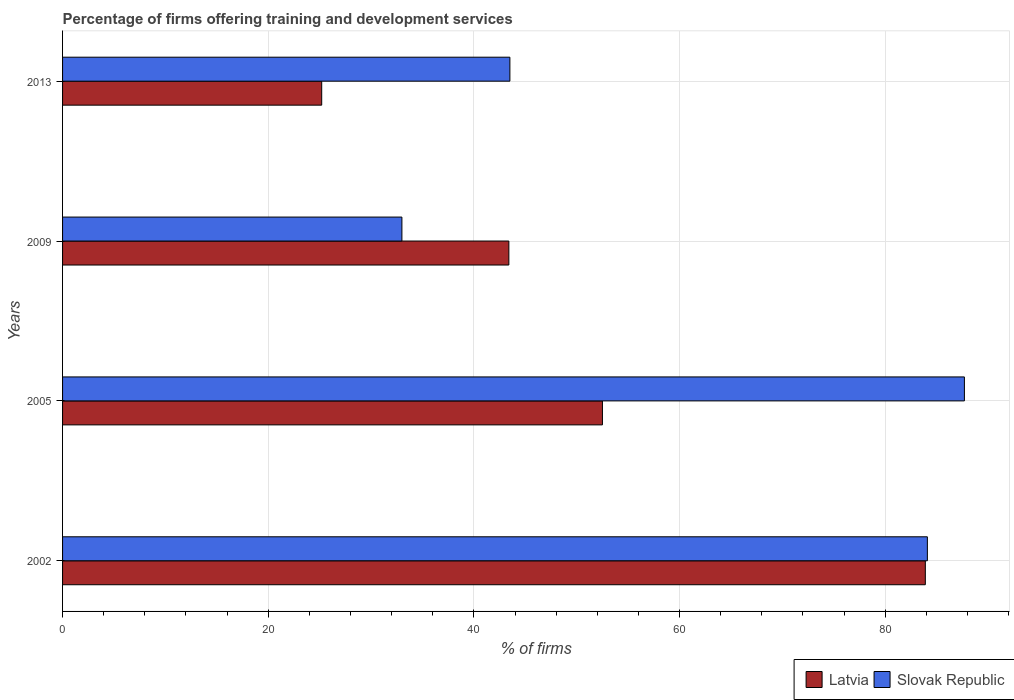How many different coloured bars are there?
Provide a short and direct response. 2. How many groups of bars are there?
Your answer should be compact. 4. Are the number of bars per tick equal to the number of legend labels?
Provide a short and direct response. Yes. Are the number of bars on each tick of the Y-axis equal?
Your response must be concise. Yes. How many bars are there on the 1st tick from the bottom?
Make the answer very short. 2. What is the percentage of firms offering training and development in Latvia in 2002?
Ensure brevity in your answer.  83.9. Across all years, what is the maximum percentage of firms offering training and development in Latvia?
Your answer should be compact. 83.9. Across all years, what is the minimum percentage of firms offering training and development in Latvia?
Give a very brief answer. 25.2. What is the total percentage of firms offering training and development in Slovak Republic in the graph?
Ensure brevity in your answer.  248.3. What is the difference between the percentage of firms offering training and development in Slovak Republic in 2002 and that in 2005?
Your response must be concise. -3.6. What is the difference between the percentage of firms offering training and development in Slovak Republic in 2005 and the percentage of firms offering training and development in Latvia in 2002?
Your answer should be very brief. 3.8. What is the average percentage of firms offering training and development in Latvia per year?
Keep it short and to the point. 51.25. In the year 2009, what is the difference between the percentage of firms offering training and development in Latvia and percentage of firms offering training and development in Slovak Republic?
Offer a terse response. 10.4. What is the ratio of the percentage of firms offering training and development in Slovak Republic in 2002 to that in 2013?
Your answer should be very brief. 1.93. Is the percentage of firms offering training and development in Latvia in 2002 less than that in 2005?
Make the answer very short. No. Is the difference between the percentage of firms offering training and development in Latvia in 2002 and 2005 greater than the difference between the percentage of firms offering training and development in Slovak Republic in 2002 and 2005?
Your answer should be compact. Yes. What is the difference between the highest and the second highest percentage of firms offering training and development in Latvia?
Ensure brevity in your answer.  31.4. What is the difference between the highest and the lowest percentage of firms offering training and development in Latvia?
Your answer should be very brief. 58.7. What does the 2nd bar from the top in 2009 represents?
Your answer should be very brief. Latvia. What does the 1st bar from the bottom in 2002 represents?
Ensure brevity in your answer.  Latvia. Are all the bars in the graph horizontal?
Your answer should be compact. Yes. How many years are there in the graph?
Provide a succinct answer. 4. Where does the legend appear in the graph?
Give a very brief answer. Bottom right. How many legend labels are there?
Give a very brief answer. 2. What is the title of the graph?
Offer a terse response. Percentage of firms offering training and development services. Does "Bahamas" appear as one of the legend labels in the graph?
Provide a short and direct response. No. What is the label or title of the X-axis?
Your answer should be very brief. % of firms. What is the % of firms of Latvia in 2002?
Your answer should be very brief. 83.9. What is the % of firms of Slovak Republic in 2002?
Ensure brevity in your answer.  84.1. What is the % of firms of Latvia in 2005?
Give a very brief answer. 52.5. What is the % of firms of Slovak Republic in 2005?
Offer a very short reply. 87.7. What is the % of firms of Latvia in 2009?
Make the answer very short. 43.4. What is the % of firms of Latvia in 2013?
Your answer should be compact. 25.2. What is the % of firms in Slovak Republic in 2013?
Make the answer very short. 43.5. Across all years, what is the maximum % of firms of Latvia?
Offer a very short reply. 83.9. Across all years, what is the maximum % of firms of Slovak Republic?
Your response must be concise. 87.7. Across all years, what is the minimum % of firms in Latvia?
Give a very brief answer. 25.2. What is the total % of firms in Latvia in the graph?
Your answer should be compact. 205. What is the total % of firms of Slovak Republic in the graph?
Your answer should be very brief. 248.3. What is the difference between the % of firms in Latvia in 2002 and that in 2005?
Offer a very short reply. 31.4. What is the difference between the % of firms in Slovak Republic in 2002 and that in 2005?
Offer a terse response. -3.6. What is the difference between the % of firms in Latvia in 2002 and that in 2009?
Keep it short and to the point. 40.5. What is the difference between the % of firms of Slovak Republic in 2002 and that in 2009?
Keep it short and to the point. 51.1. What is the difference between the % of firms in Latvia in 2002 and that in 2013?
Your answer should be very brief. 58.7. What is the difference between the % of firms of Slovak Republic in 2002 and that in 2013?
Your response must be concise. 40.6. What is the difference between the % of firms of Slovak Republic in 2005 and that in 2009?
Your answer should be compact. 54.7. What is the difference between the % of firms in Latvia in 2005 and that in 2013?
Give a very brief answer. 27.3. What is the difference between the % of firms of Slovak Republic in 2005 and that in 2013?
Make the answer very short. 44.2. What is the difference between the % of firms in Latvia in 2009 and that in 2013?
Ensure brevity in your answer.  18.2. What is the difference between the % of firms of Slovak Republic in 2009 and that in 2013?
Offer a terse response. -10.5. What is the difference between the % of firms in Latvia in 2002 and the % of firms in Slovak Republic in 2005?
Offer a very short reply. -3.8. What is the difference between the % of firms of Latvia in 2002 and the % of firms of Slovak Republic in 2009?
Your answer should be compact. 50.9. What is the difference between the % of firms of Latvia in 2002 and the % of firms of Slovak Republic in 2013?
Provide a succinct answer. 40.4. What is the average % of firms of Latvia per year?
Offer a terse response. 51.25. What is the average % of firms of Slovak Republic per year?
Provide a succinct answer. 62.08. In the year 2002, what is the difference between the % of firms in Latvia and % of firms in Slovak Republic?
Ensure brevity in your answer.  -0.2. In the year 2005, what is the difference between the % of firms of Latvia and % of firms of Slovak Republic?
Offer a very short reply. -35.2. In the year 2013, what is the difference between the % of firms in Latvia and % of firms in Slovak Republic?
Your answer should be very brief. -18.3. What is the ratio of the % of firms of Latvia in 2002 to that in 2005?
Provide a succinct answer. 1.6. What is the ratio of the % of firms of Latvia in 2002 to that in 2009?
Provide a succinct answer. 1.93. What is the ratio of the % of firms of Slovak Republic in 2002 to that in 2009?
Offer a terse response. 2.55. What is the ratio of the % of firms in Latvia in 2002 to that in 2013?
Offer a terse response. 3.33. What is the ratio of the % of firms in Slovak Republic in 2002 to that in 2013?
Your answer should be very brief. 1.93. What is the ratio of the % of firms of Latvia in 2005 to that in 2009?
Give a very brief answer. 1.21. What is the ratio of the % of firms in Slovak Republic in 2005 to that in 2009?
Provide a succinct answer. 2.66. What is the ratio of the % of firms in Latvia in 2005 to that in 2013?
Provide a succinct answer. 2.08. What is the ratio of the % of firms in Slovak Republic in 2005 to that in 2013?
Keep it short and to the point. 2.02. What is the ratio of the % of firms in Latvia in 2009 to that in 2013?
Your response must be concise. 1.72. What is the ratio of the % of firms of Slovak Republic in 2009 to that in 2013?
Provide a succinct answer. 0.76. What is the difference between the highest and the second highest % of firms in Latvia?
Your answer should be very brief. 31.4. What is the difference between the highest and the lowest % of firms of Latvia?
Make the answer very short. 58.7. What is the difference between the highest and the lowest % of firms of Slovak Republic?
Your response must be concise. 54.7. 